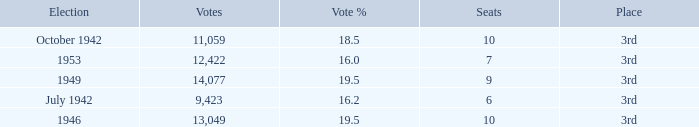Name the vote % for seats of 9 19.5. 